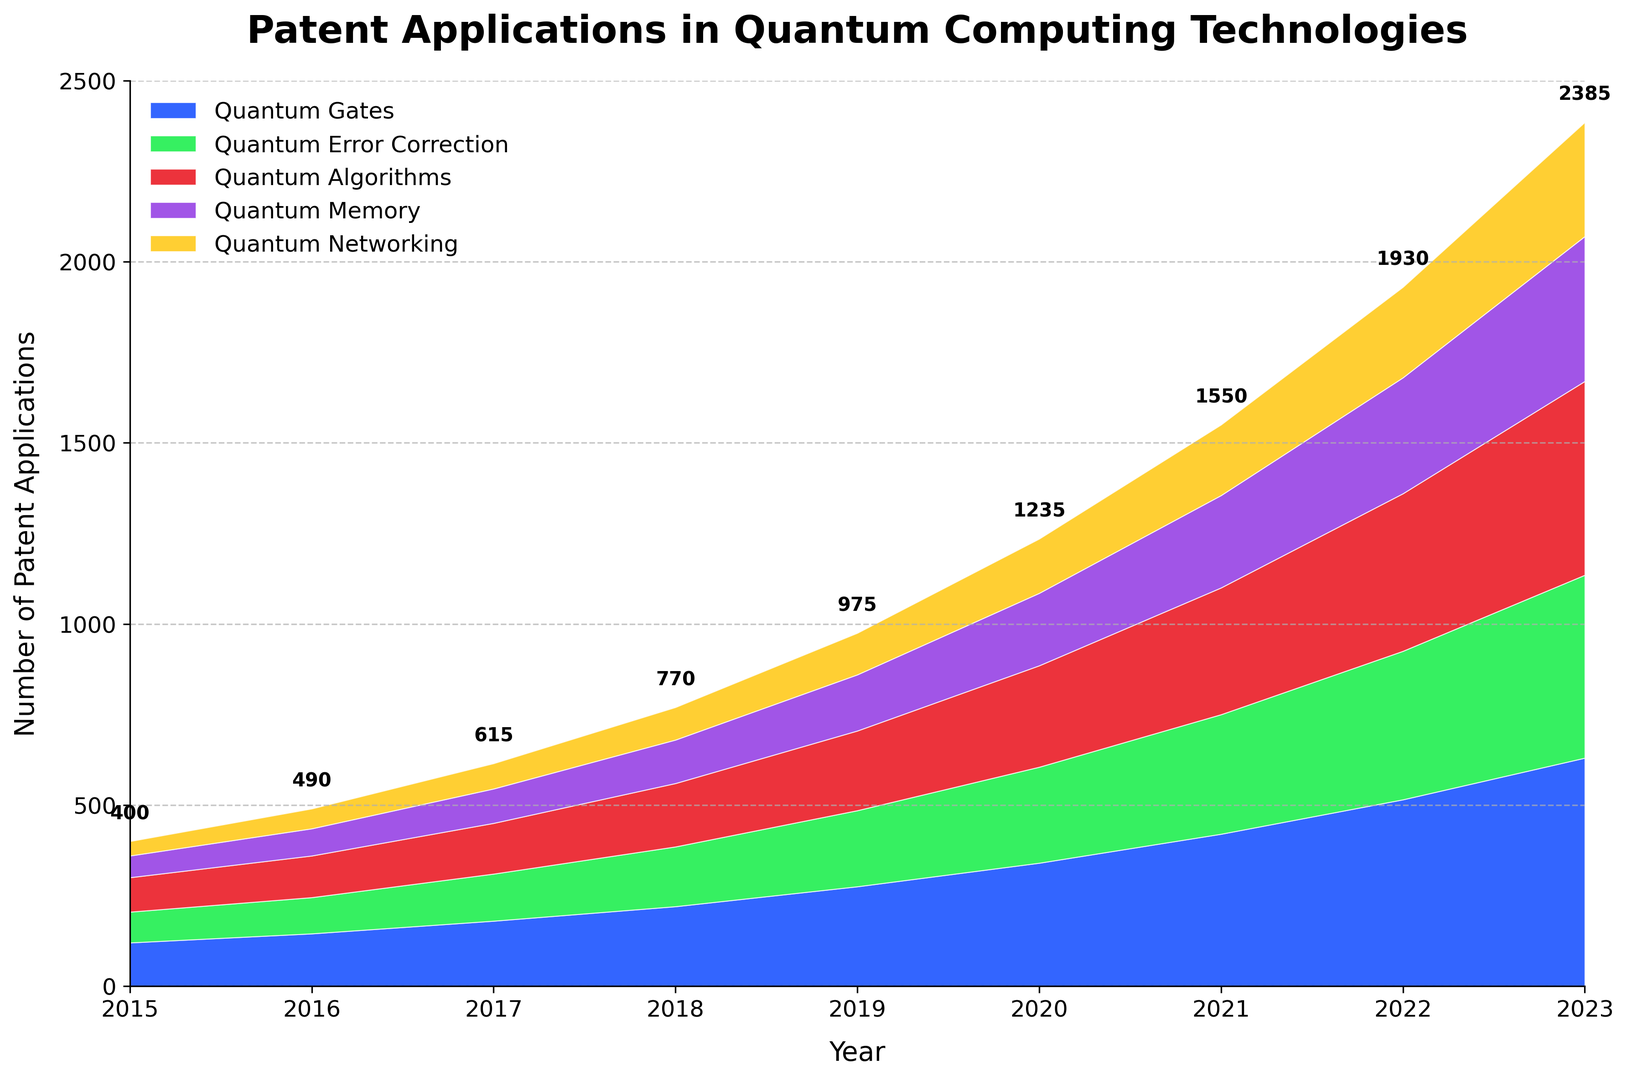What year saw the steepest increase in the total number of patent applications across all subfields? By examining the figure, identify the year-over-year increases in the total patent applications. The year with the largest increase will be the one where the cumulative area shows the most significant growth.
Answer: 2023 Which quantum computing subfield consistently had the smallest number of patent applications from 2015 to 2023? Looking at the area chart, the subfield with the smallest area at the bottom represents the quantum computing subfield with the fewest patent applications.
Answer: Quantum Networking By how much did the total number of patent applications in 2023 exceed that in 2015? First, find the total number of patent applications for both years by summing up the values for each subfield. Then, calculate the difference: 630+505+535+400+315 for 2023 and 120+85+95+60+40 for 2015. 2385 - 400 = 1985.
Answer: 1985 Between 2016 and 2022, which subfield exhibited the highest growth rate in patent applications? For each subfield, subtract the number of patent applications in 2016 from that in 2022 and compare the differences. Higher differences indicate higher growth rates.
Answer: Quantum Gates How did the patent applications in Quantum Memory change from 2020 to 2023? Compare the height of the area representing Quantum Memory in 2020 and 2023: Quantum Memory in 2020 is 200 and in 2023 is 400.
Answer: Increased by 200 What was the total number of patent applications in 2020? Add the values of all subfields for that year (340 + 265 + 280 + 200 + 150).
Answer: 1235 Which two subfields showed the closest number of patent applications in 2017? Compare the height of the stacked areas for each subfield in 2017. Identify the two areas that are closest in size: Quantum Error Correction (130) and Quantum Algorithms (140).
Answer: Quantum Error Correction and Quantum Algorithms Did the total number of patent applications increase every year from 2015 to 2023? Check the total patent applications in each consecutive year. If each year shows an increase compared to the previous one, then the total number increased every year.
Answer: Yes Which year had the highest amount of patent applications specifically for Quantum Algorithms? Look at the height of the quantum algorithms section each year and find the year with the highest value, which is 2023 with 535.
Answer: 2023 